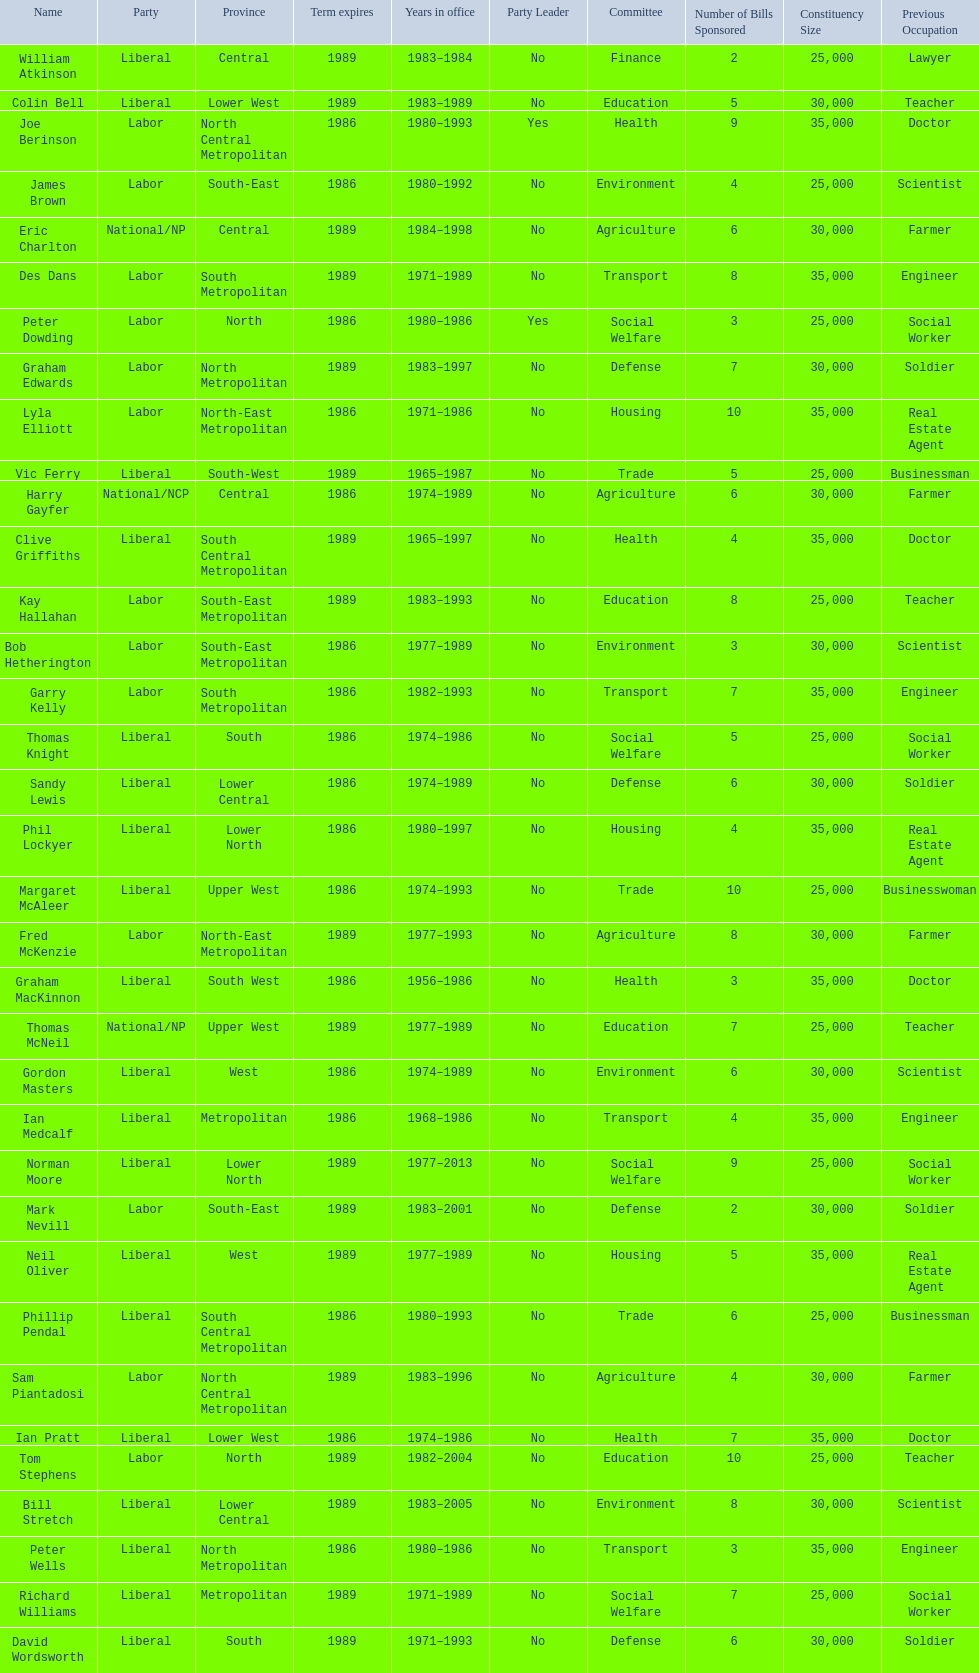How many members will have their terms end in 1989? 9. 